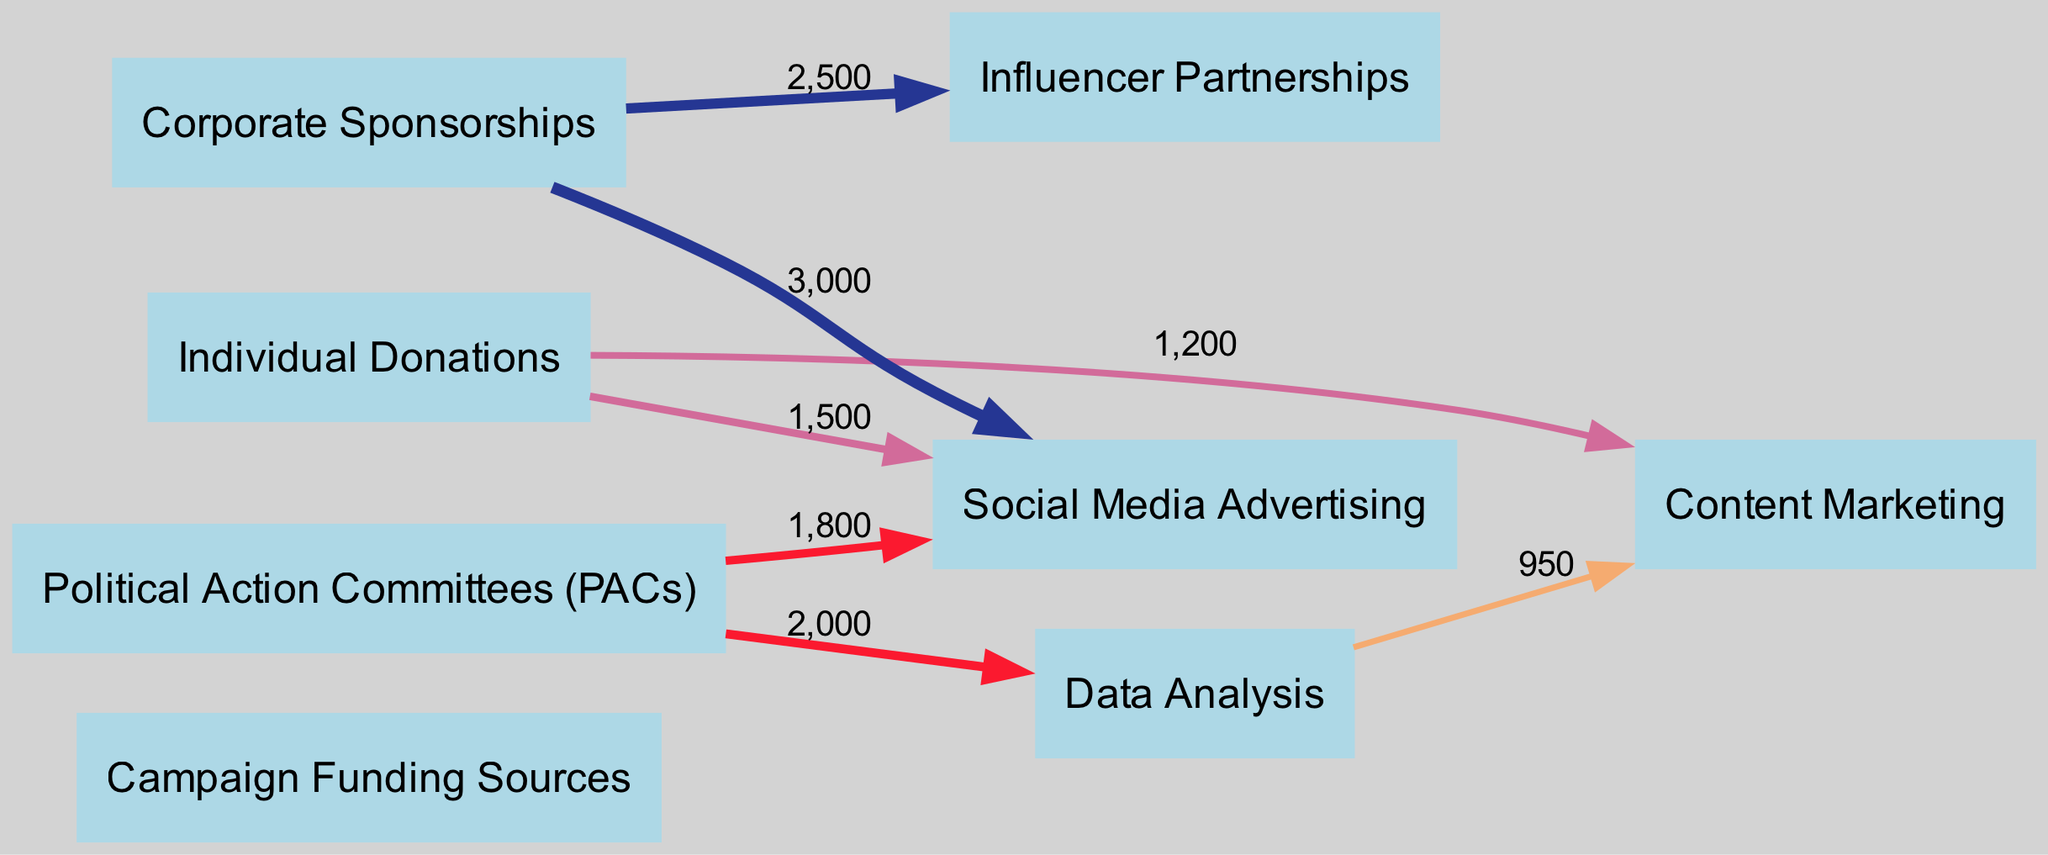What is the total value of funding from individual donations? To find the total value from individual donations, I review the links where the source is "individual_donations". There are two links: one to "social_media_advertising" with a value of 1500 and one to "content_marketing" with a value of 1200. Adding these together gives 1500 + 1200 = 2700.
Answer: 2700 Which digital marketing strategy received the highest allocation from corporate sponsorships? Looking at the links from "corporate_sponsorships", I see two connections: to "influencer_partnerships" (value 2500) and to "social_media_advertising" (value 3000). The higher value indicates that "social_media_advertising" received the most funding from this source.
Answer: Social Media Advertising How many unique campaign funding sources are represented in the diagram? I count the distinct sources listed in the nodes under "Campaign Funding Sources". There are three unique sources: "individual_donations", "corporate_sponsorships", and "political_action_committees". Thus, the total is three.
Answer: 3 What is the value allocated to data analysis by political action committees? I find the specific link where the source is "political_action_committees" and the target is "data_analysis". The respective link shows a value of 2000 allocated to data analysis.
Answer: 2000 Which marketing strategy has the lowest combined funding from individual donations? Analyzing the total funds allocated from "individual_donations", I see funding to "social_media_advertising" (1500) and "content_marketing" (1200). The lowest value is from "content_marketing" at 1200.
Answer: Content Marketing What is the total value flowing into social media advertising? To calculate the total inflow to "social_media_advertising", I check all incoming links: from "individual_donations" (1500), "corporate_sponsorships" (3000), and "political_action_committees" (1800). Adding these values gives 1500 + 3000 + 1800 = 6300.
Answer: 6300 Which node has the lowest outgoing flow in the diagram? I evaluate all nodes by examining their outgoing links: "individual_donations" has two connections, "corporate_sponsorships" has two, "political_action_committees" has two, "data_analysis" has one to "content_marketing" (950), while the others have higher values. Hence, "data_analysis" has the lowest outgoing flow.
Answer: Data Analysis 